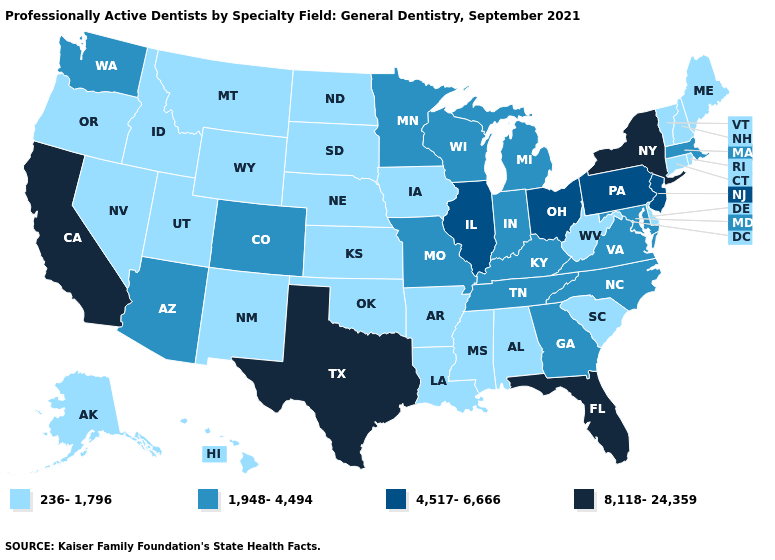What is the highest value in the Northeast ?
Be succinct. 8,118-24,359. What is the lowest value in the South?
Quick response, please. 236-1,796. Name the states that have a value in the range 1,948-4,494?
Concise answer only. Arizona, Colorado, Georgia, Indiana, Kentucky, Maryland, Massachusetts, Michigan, Minnesota, Missouri, North Carolina, Tennessee, Virginia, Washington, Wisconsin. Does the map have missing data?
Quick response, please. No. Does Wisconsin have a higher value than Rhode Island?
Concise answer only. Yes. What is the value of Alaska?
Write a very short answer. 236-1,796. What is the highest value in the USA?
Write a very short answer. 8,118-24,359. What is the value of Iowa?
Concise answer only. 236-1,796. What is the value of Rhode Island?
Concise answer only. 236-1,796. Which states have the lowest value in the USA?
Short answer required. Alabama, Alaska, Arkansas, Connecticut, Delaware, Hawaii, Idaho, Iowa, Kansas, Louisiana, Maine, Mississippi, Montana, Nebraska, Nevada, New Hampshire, New Mexico, North Dakota, Oklahoma, Oregon, Rhode Island, South Carolina, South Dakota, Utah, Vermont, West Virginia, Wyoming. What is the value of Michigan?
Be succinct. 1,948-4,494. What is the value of Maryland?
Be succinct. 1,948-4,494. Among the states that border Colorado , does New Mexico have the lowest value?
Give a very brief answer. Yes. Does South Dakota have the highest value in the USA?
Be succinct. No. What is the highest value in the USA?
Concise answer only. 8,118-24,359. 